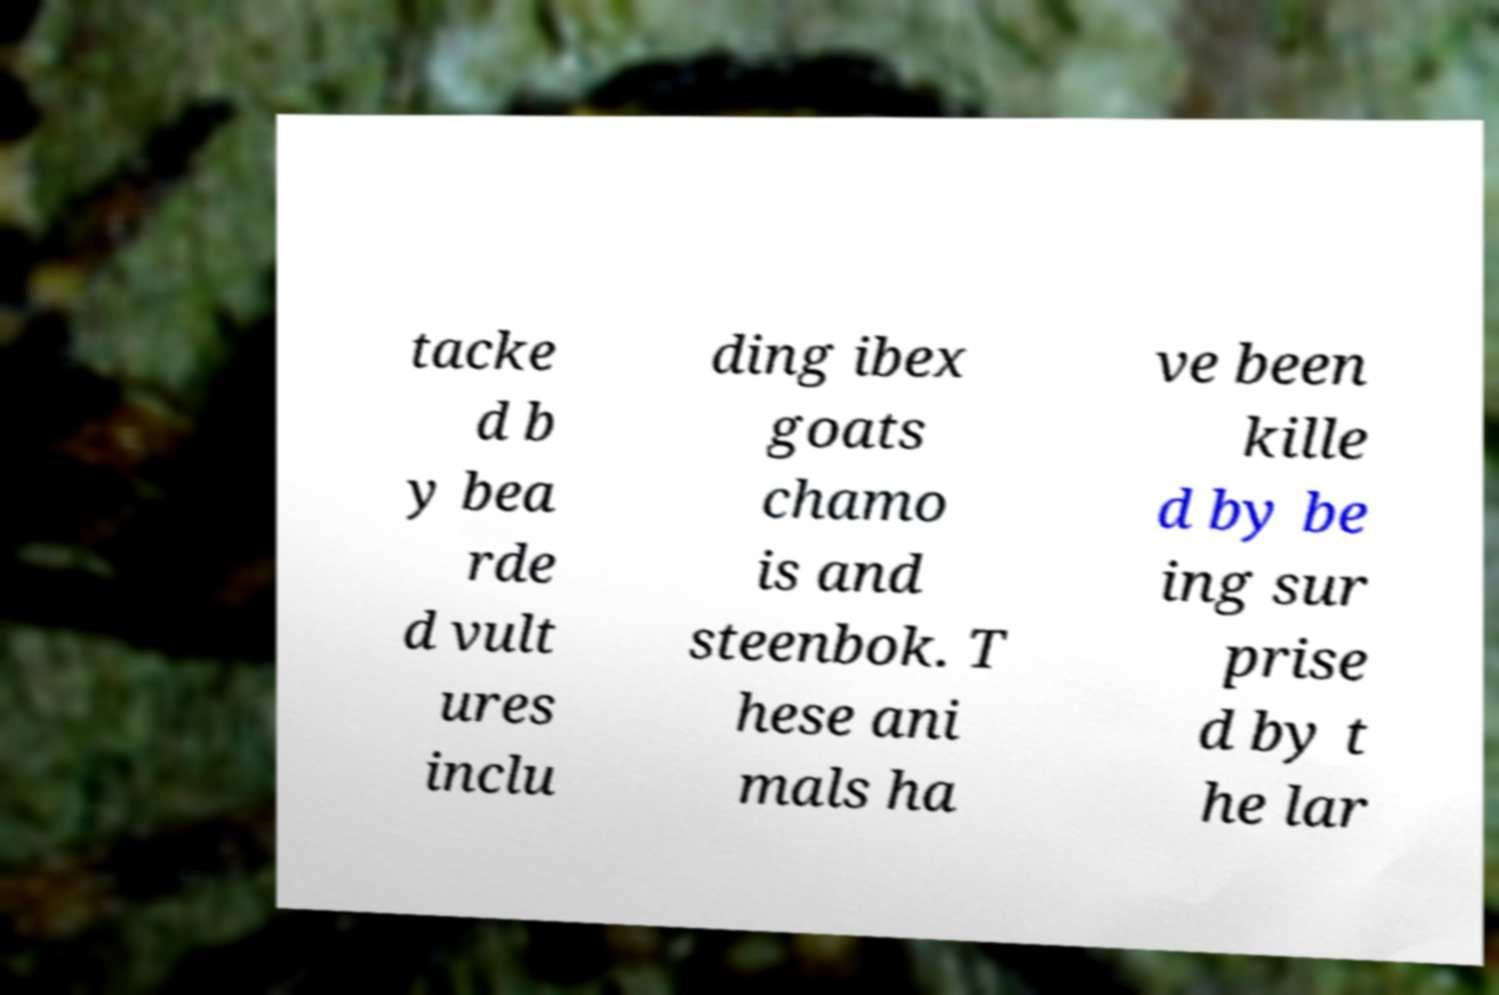Can you read and provide the text displayed in the image?This photo seems to have some interesting text. Can you extract and type it out for me? tacke d b y bea rde d vult ures inclu ding ibex goats chamo is and steenbok. T hese ani mals ha ve been kille d by be ing sur prise d by t he lar 